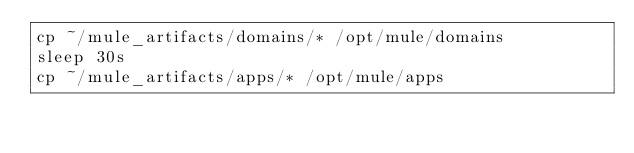Convert code to text. <code><loc_0><loc_0><loc_500><loc_500><_Bash_>cp ~/mule_artifacts/domains/* /opt/mule/domains
sleep 30s
cp ~/mule_artifacts/apps/* /opt/mule/apps
</code> 